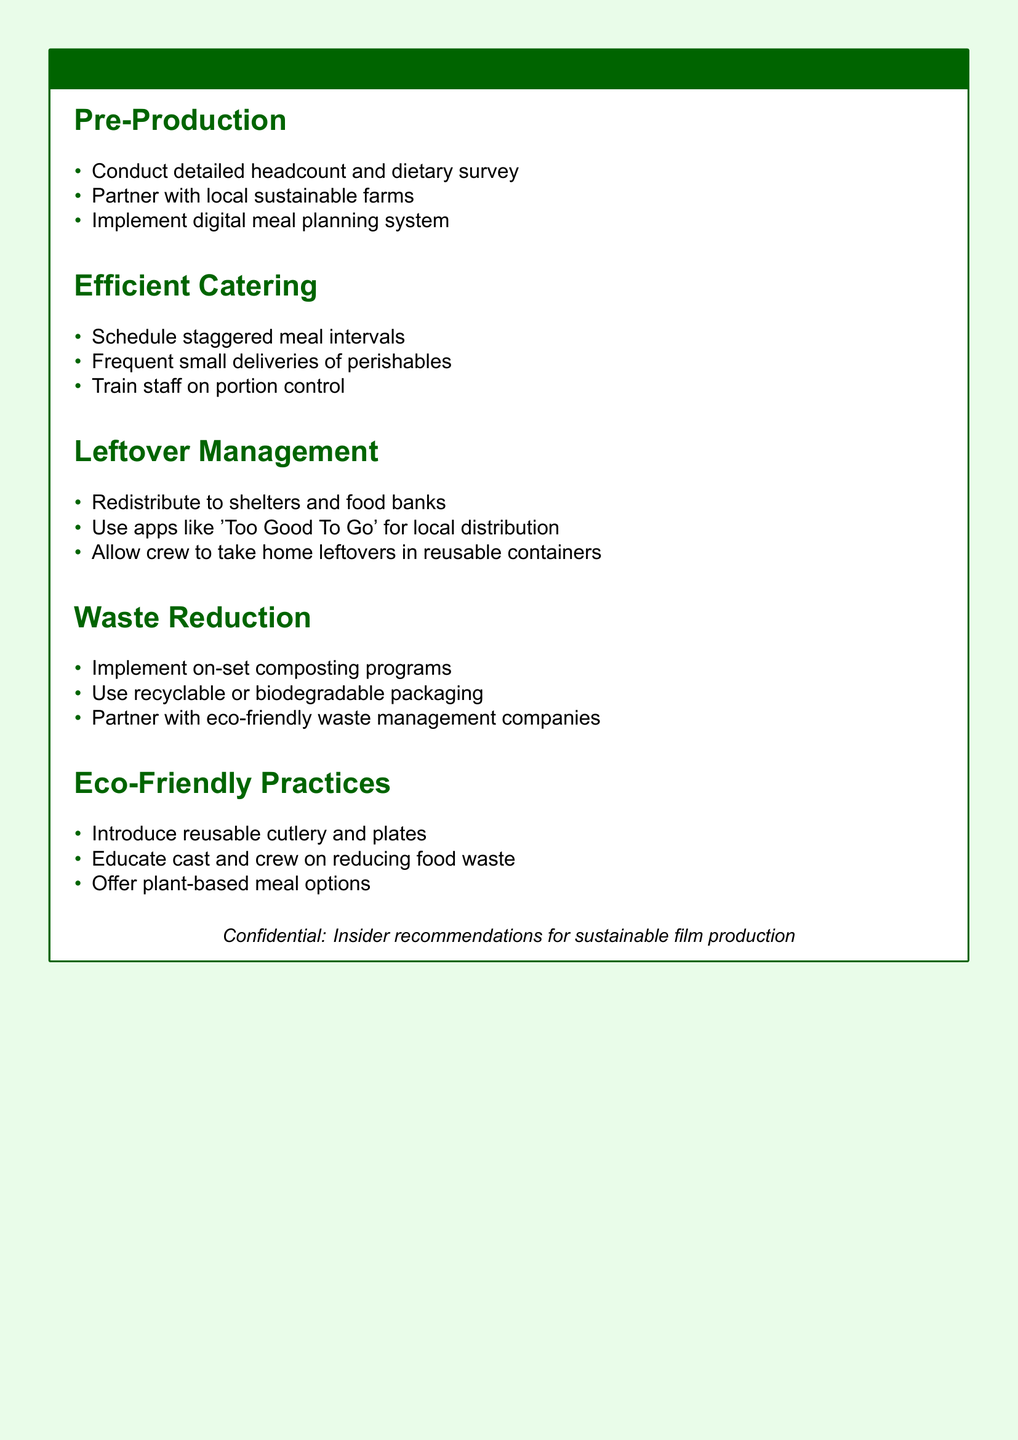What are the three sections outlined in the meal plan? The meal plan includes various sections detailing strategies to minimize food waste and promote eco-friendly practices, which are: Pre-Production, Efficient Catering, Leftover Management, Waste Reduction, and Eco-Friendly Practices.
Answer: Pre-Production, Efficient Catering, Leftover Management, Waste Reduction, Eco-Friendly Practices How can the crew take home leftovers? The document lists a specific practice that allows crew members to take home leftovers, promoting sustainable habits.
Answer: In reusable containers What should be partnered with local sustainable farms? A recommendation in the meal plan emphasizes building relationships with specific types of suppliers that align with eco-friendly practices.
Answer: Caterers What is a recommended method for waste reduction? The document outlines several strategies, and one specific technique is highlighted for effective waste management on film sets.
Answer: On-set composting programs How often should deliveries of perishables be made? The meal plan suggests a frequency that aids in maintaining freshness while reducing waste through logistical improvements.
Answer: Frequent small deliveries 